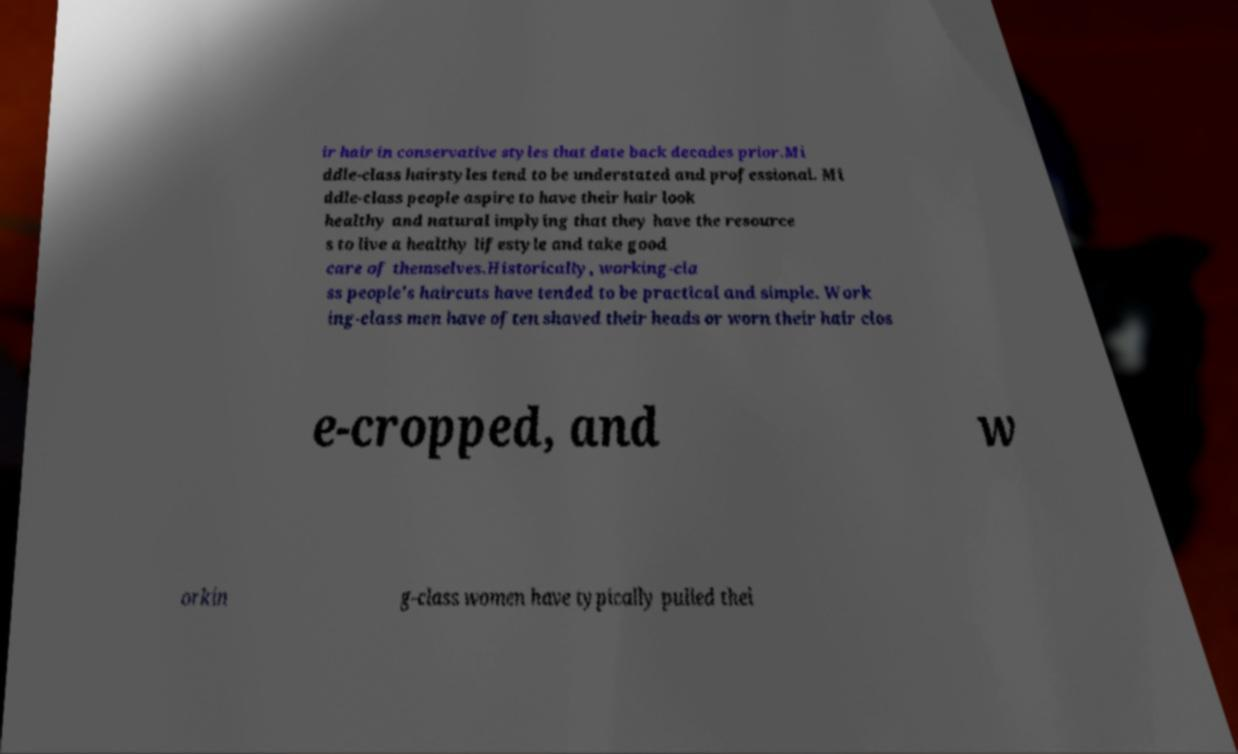I need the written content from this picture converted into text. Can you do that? ir hair in conservative styles that date back decades prior.Mi ddle-class hairstyles tend to be understated and professional. Mi ddle-class people aspire to have their hair look healthy and natural implying that they have the resource s to live a healthy lifestyle and take good care of themselves.Historically, working-cla ss people's haircuts have tended to be practical and simple. Work ing-class men have often shaved their heads or worn their hair clos e-cropped, and w orkin g-class women have typically pulled thei 